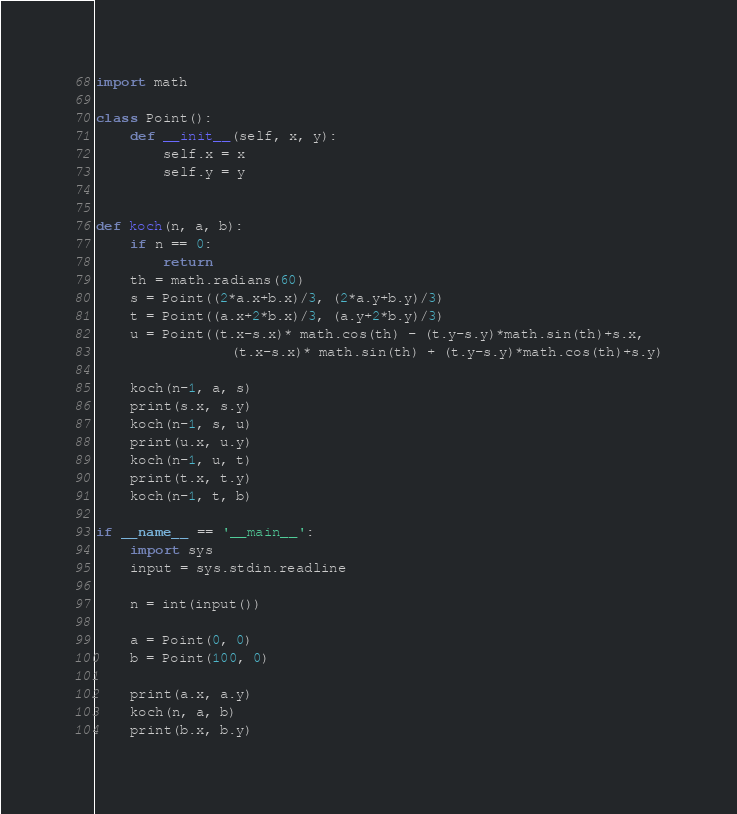Convert code to text. <code><loc_0><loc_0><loc_500><loc_500><_Python_>import math

class Point():
    def __init__(self, x, y):
        self.x = x
        self.y = y


def koch(n, a, b):
    if n == 0:
        return
    th = math.radians(60)
    s = Point((2*a.x+b.x)/3, (2*a.y+b.y)/3)
    t = Point((a.x+2*b.x)/3, (a.y+2*b.y)/3)
    u = Point((t.x-s.x)* math.cos(th) - (t.y-s.y)*math.sin(th)+s.x,
                (t.x-s.x)* math.sin(th) + (t.y-s.y)*math.cos(th)+s.y)

    koch(n-1, a, s)
    print(s.x, s.y)
    koch(n-1, s, u)
    print(u.x, u.y)
    koch(n-1, u, t)
    print(t.x, t.y)
    koch(n-1, t, b)

if __name__ == '__main__':
    import sys
    input = sys.stdin.readline

    n = int(input())

    a = Point(0, 0)
    b = Point(100, 0)

    print(a.x, a.y)
    koch(n, a, b)
    print(b.x, b.y)

</code> 